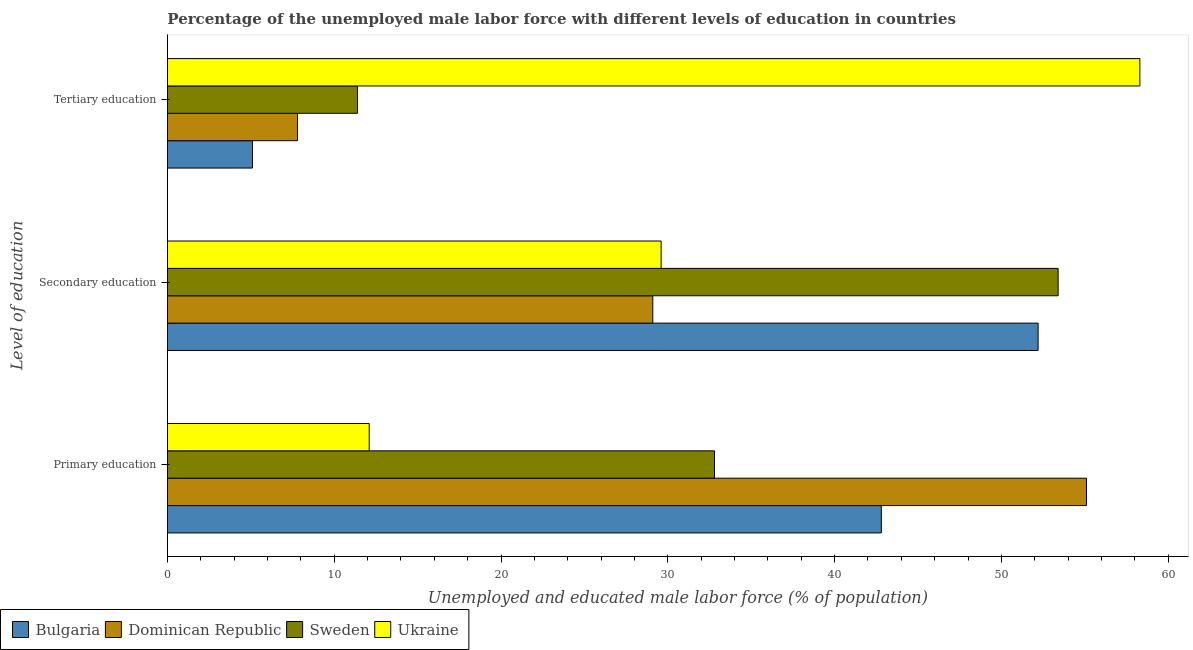How many different coloured bars are there?
Keep it short and to the point. 4. How many groups of bars are there?
Offer a very short reply. 3. Are the number of bars per tick equal to the number of legend labels?
Give a very brief answer. Yes. Are the number of bars on each tick of the Y-axis equal?
Your answer should be very brief. Yes. How many bars are there on the 2nd tick from the bottom?
Offer a very short reply. 4. What is the label of the 1st group of bars from the top?
Your response must be concise. Tertiary education. What is the percentage of male labor force who received tertiary education in Bulgaria?
Offer a terse response. 5.1. Across all countries, what is the maximum percentage of male labor force who received tertiary education?
Your response must be concise. 58.3. Across all countries, what is the minimum percentage of male labor force who received tertiary education?
Your answer should be compact. 5.1. In which country was the percentage of male labor force who received tertiary education maximum?
Give a very brief answer. Ukraine. What is the total percentage of male labor force who received tertiary education in the graph?
Your response must be concise. 82.6. What is the difference between the percentage of male labor force who received primary education in Bulgaria and that in Dominican Republic?
Give a very brief answer. -12.3. What is the difference between the percentage of male labor force who received primary education in Bulgaria and the percentage of male labor force who received secondary education in Dominican Republic?
Provide a short and direct response. 13.7. What is the average percentage of male labor force who received secondary education per country?
Your answer should be compact. 41.08. What is the difference between the percentage of male labor force who received primary education and percentage of male labor force who received secondary education in Ukraine?
Ensure brevity in your answer.  -17.5. In how many countries, is the percentage of male labor force who received primary education greater than 12 %?
Give a very brief answer. 4. What is the ratio of the percentage of male labor force who received primary education in Ukraine to that in Sweden?
Your response must be concise. 0.37. What is the difference between the highest and the second highest percentage of male labor force who received secondary education?
Offer a very short reply. 1.2. What is the difference between the highest and the lowest percentage of male labor force who received primary education?
Make the answer very short. 43. In how many countries, is the percentage of male labor force who received tertiary education greater than the average percentage of male labor force who received tertiary education taken over all countries?
Offer a very short reply. 1. What does the 4th bar from the top in Primary education represents?
Provide a short and direct response. Bulgaria. What does the 4th bar from the bottom in Secondary education represents?
Provide a succinct answer. Ukraine. What is the difference between two consecutive major ticks on the X-axis?
Offer a very short reply. 10. Does the graph contain any zero values?
Your answer should be compact. No. Where does the legend appear in the graph?
Your response must be concise. Bottom left. What is the title of the graph?
Ensure brevity in your answer.  Percentage of the unemployed male labor force with different levels of education in countries. Does "Uzbekistan" appear as one of the legend labels in the graph?
Your answer should be very brief. No. What is the label or title of the X-axis?
Your answer should be very brief. Unemployed and educated male labor force (% of population). What is the label or title of the Y-axis?
Your answer should be very brief. Level of education. What is the Unemployed and educated male labor force (% of population) of Bulgaria in Primary education?
Make the answer very short. 42.8. What is the Unemployed and educated male labor force (% of population) of Dominican Republic in Primary education?
Provide a succinct answer. 55.1. What is the Unemployed and educated male labor force (% of population) of Sweden in Primary education?
Ensure brevity in your answer.  32.8. What is the Unemployed and educated male labor force (% of population) of Ukraine in Primary education?
Your answer should be compact. 12.1. What is the Unemployed and educated male labor force (% of population) of Bulgaria in Secondary education?
Offer a very short reply. 52.2. What is the Unemployed and educated male labor force (% of population) of Dominican Republic in Secondary education?
Offer a very short reply. 29.1. What is the Unemployed and educated male labor force (% of population) of Sweden in Secondary education?
Provide a short and direct response. 53.4. What is the Unemployed and educated male labor force (% of population) of Ukraine in Secondary education?
Your response must be concise. 29.6. What is the Unemployed and educated male labor force (% of population) of Bulgaria in Tertiary education?
Make the answer very short. 5.1. What is the Unemployed and educated male labor force (% of population) in Dominican Republic in Tertiary education?
Ensure brevity in your answer.  7.8. What is the Unemployed and educated male labor force (% of population) in Sweden in Tertiary education?
Your answer should be compact. 11.4. What is the Unemployed and educated male labor force (% of population) in Ukraine in Tertiary education?
Provide a succinct answer. 58.3. Across all Level of education, what is the maximum Unemployed and educated male labor force (% of population) in Bulgaria?
Provide a succinct answer. 52.2. Across all Level of education, what is the maximum Unemployed and educated male labor force (% of population) of Dominican Republic?
Provide a succinct answer. 55.1. Across all Level of education, what is the maximum Unemployed and educated male labor force (% of population) of Sweden?
Give a very brief answer. 53.4. Across all Level of education, what is the maximum Unemployed and educated male labor force (% of population) in Ukraine?
Make the answer very short. 58.3. Across all Level of education, what is the minimum Unemployed and educated male labor force (% of population) in Bulgaria?
Offer a terse response. 5.1. Across all Level of education, what is the minimum Unemployed and educated male labor force (% of population) of Dominican Republic?
Provide a succinct answer. 7.8. Across all Level of education, what is the minimum Unemployed and educated male labor force (% of population) of Sweden?
Offer a very short reply. 11.4. Across all Level of education, what is the minimum Unemployed and educated male labor force (% of population) of Ukraine?
Offer a terse response. 12.1. What is the total Unemployed and educated male labor force (% of population) in Bulgaria in the graph?
Make the answer very short. 100.1. What is the total Unemployed and educated male labor force (% of population) of Dominican Republic in the graph?
Keep it short and to the point. 92. What is the total Unemployed and educated male labor force (% of population) in Sweden in the graph?
Make the answer very short. 97.6. What is the difference between the Unemployed and educated male labor force (% of population) of Bulgaria in Primary education and that in Secondary education?
Offer a terse response. -9.4. What is the difference between the Unemployed and educated male labor force (% of population) of Sweden in Primary education and that in Secondary education?
Your answer should be compact. -20.6. What is the difference between the Unemployed and educated male labor force (% of population) in Ukraine in Primary education and that in Secondary education?
Your response must be concise. -17.5. What is the difference between the Unemployed and educated male labor force (% of population) in Bulgaria in Primary education and that in Tertiary education?
Offer a terse response. 37.7. What is the difference between the Unemployed and educated male labor force (% of population) of Dominican Republic in Primary education and that in Tertiary education?
Offer a very short reply. 47.3. What is the difference between the Unemployed and educated male labor force (% of population) in Sweden in Primary education and that in Tertiary education?
Ensure brevity in your answer.  21.4. What is the difference between the Unemployed and educated male labor force (% of population) in Ukraine in Primary education and that in Tertiary education?
Your answer should be very brief. -46.2. What is the difference between the Unemployed and educated male labor force (% of population) in Bulgaria in Secondary education and that in Tertiary education?
Provide a succinct answer. 47.1. What is the difference between the Unemployed and educated male labor force (% of population) of Dominican Republic in Secondary education and that in Tertiary education?
Provide a short and direct response. 21.3. What is the difference between the Unemployed and educated male labor force (% of population) in Ukraine in Secondary education and that in Tertiary education?
Your answer should be very brief. -28.7. What is the difference between the Unemployed and educated male labor force (% of population) in Dominican Republic in Primary education and the Unemployed and educated male labor force (% of population) in Sweden in Secondary education?
Your response must be concise. 1.7. What is the difference between the Unemployed and educated male labor force (% of population) of Dominican Republic in Primary education and the Unemployed and educated male labor force (% of population) of Ukraine in Secondary education?
Offer a very short reply. 25.5. What is the difference between the Unemployed and educated male labor force (% of population) in Bulgaria in Primary education and the Unemployed and educated male labor force (% of population) in Dominican Republic in Tertiary education?
Offer a very short reply. 35. What is the difference between the Unemployed and educated male labor force (% of population) in Bulgaria in Primary education and the Unemployed and educated male labor force (% of population) in Sweden in Tertiary education?
Offer a terse response. 31.4. What is the difference between the Unemployed and educated male labor force (% of population) of Bulgaria in Primary education and the Unemployed and educated male labor force (% of population) of Ukraine in Tertiary education?
Keep it short and to the point. -15.5. What is the difference between the Unemployed and educated male labor force (% of population) of Dominican Republic in Primary education and the Unemployed and educated male labor force (% of population) of Sweden in Tertiary education?
Offer a very short reply. 43.7. What is the difference between the Unemployed and educated male labor force (% of population) in Dominican Republic in Primary education and the Unemployed and educated male labor force (% of population) in Ukraine in Tertiary education?
Your answer should be very brief. -3.2. What is the difference between the Unemployed and educated male labor force (% of population) of Sweden in Primary education and the Unemployed and educated male labor force (% of population) of Ukraine in Tertiary education?
Your answer should be very brief. -25.5. What is the difference between the Unemployed and educated male labor force (% of population) of Bulgaria in Secondary education and the Unemployed and educated male labor force (% of population) of Dominican Republic in Tertiary education?
Provide a short and direct response. 44.4. What is the difference between the Unemployed and educated male labor force (% of population) in Bulgaria in Secondary education and the Unemployed and educated male labor force (% of population) in Sweden in Tertiary education?
Your answer should be very brief. 40.8. What is the difference between the Unemployed and educated male labor force (% of population) in Dominican Republic in Secondary education and the Unemployed and educated male labor force (% of population) in Ukraine in Tertiary education?
Provide a succinct answer. -29.2. What is the average Unemployed and educated male labor force (% of population) in Bulgaria per Level of education?
Make the answer very short. 33.37. What is the average Unemployed and educated male labor force (% of population) in Dominican Republic per Level of education?
Provide a succinct answer. 30.67. What is the average Unemployed and educated male labor force (% of population) in Sweden per Level of education?
Provide a short and direct response. 32.53. What is the average Unemployed and educated male labor force (% of population) in Ukraine per Level of education?
Provide a succinct answer. 33.33. What is the difference between the Unemployed and educated male labor force (% of population) of Bulgaria and Unemployed and educated male labor force (% of population) of Ukraine in Primary education?
Your response must be concise. 30.7. What is the difference between the Unemployed and educated male labor force (% of population) of Dominican Republic and Unemployed and educated male labor force (% of population) of Sweden in Primary education?
Offer a terse response. 22.3. What is the difference between the Unemployed and educated male labor force (% of population) in Dominican Republic and Unemployed and educated male labor force (% of population) in Ukraine in Primary education?
Your answer should be compact. 43. What is the difference between the Unemployed and educated male labor force (% of population) in Sweden and Unemployed and educated male labor force (% of population) in Ukraine in Primary education?
Make the answer very short. 20.7. What is the difference between the Unemployed and educated male labor force (% of population) of Bulgaria and Unemployed and educated male labor force (% of population) of Dominican Republic in Secondary education?
Keep it short and to the point. 23.1. What is the difference between the Unemployed and educated male labor force (% of population) of Bulgaria and Unemployed and educated male labor force (% of population) of Ukraine in Secondary education?
Ensure brevity in your answer.  22.6. What is the difference between the Unemployed and educated male labor force (% of population) of Dominican Republic and Unemployed and educated male labor force (% of population) of Sweden in Secondary education?
Offer a very short reply. -24.3. What is the difference between the Unemployed and educated male labor force (% of population) in Sweden and Unemployed and educated male labor force (% of population) in Ukraine in Secondary education?
Make the answer very short. 23.8. What is the difference between the Unemployed and educated male labor force (% of population) of Bulgaria and Unemployed and educated male labor force (% of population) of Dominican Republic in Tertiary education?
Ensure brevity in your answer.  -2.7. What is the difference between the Unemployed and educated male labor force (% of population) of Bulgaria and Unemployed and educated male labor force (% of population) of Sweden in Tertiary education?
Ensure brevity in your answer.  -6.3. What is the difference between the Unemployed and educated male labor force (% of population) in Bulgaria and Unemployed and educated male labor force (% of population) in Ukraine in Tertiary education?
Keep it short and to the point. -53.2. What is the difference between the Unemployed and educated male labor force (% of population) in Dominican Republic and Unemployed and educated male labor force (% of population) in Ukraine in Tertiary education?
Offer a terse response. -50.5. What is the difference between the Unemployed and educated male labor force (% of population) in Sweden and Unemployed and educated male labor force (% of population) in Ukraine in Tertiary education?
Offer a terse response. -46.9. What is the ratio of the Unemployed and educated male labor force (% of population) of Bulgaria in Primary education to that in Secondary education?
Provide a short and direct response. 0.82. What is the ratio of the Unemployed and educated male labor force (% of population) of Dominican Republic in Primary education to that in Secondary education?
Give a very brief answer. 1.89. What is the ratio of the Unemployed and educated male labor force (% of population) of Sweden in Primary education to that in Secondary education?
Offer a very short reply. 0.61. What is the ratio of the Unemployed and educated male labor force (% of population) of Ukraine in Primary education to that in Secondary education?
Your answer should be compact. 0.41. What is the ratio of the Unemployed and educated male labor force (% of population) in Bulgaria in Primary education to that in Tertiary education?
Your answer should be compact. 8.39. What is the ratio of the Unemployed and educated male labor force (% of population) of Dominican Republic in Primary education to that in Tertiary education?
Make the answer very short. 7.06. What is the ratio of the Unemployed and educated male labor force (% of population) of Sweden in Primary education to that in Tertiary education?
Provide a short and direct response. 2.88. What is the ratio of the Unemployed and educated male labor force (% of population) of Ukraine in Primary education to that in Tertiary education?
Offer a terse response. 0.21. What is the ratio of the Unemployed and educated male labor force (% of population) of Bulgaria in Secondary education to that in Tertiary education?
Keep it short and to the point. 10.24. What is the ratio of the Unemployed and educated male labor force (% of population) in Dominican Republic in Secondary education to that in Tertiary education?
Offer a terse response. 3.73. What is the ratio of the Unemployed and educated male labor force (% of population) in Sweden in Secondary education to that in Tertiary education?
Ensure brevity in your answer.  4.68. What is the ratio of the Unemployed and educated male labor force (% of population) in Ukraine in Secondary education to that in Tertiary education?
Provide a succinct answer. 0.51. What is the difference between the highest and the second highest Unemployed and educated male labor force (% of population) in Bulgaria?
Your answer should be very brief. 9.4. What is the difference between the highest and the second highest Unemployed and educated male labor force (% of population) in Dominican Republic?
Your answer should be very brief. 26. What is the difference between the highest and the second highest Unemployed and educated male labor force (% of population) in Sweden?
Your answer should be compact. 20.6. What is the difference between the highest and the second highest Unemployed and educated male labor force (% of population) in Ukraine?
Provide a short and direct response. 28.7. What is the difference between the highest and the lowest Unemployed and educated male labor force (% of population) of Bulgaria?
Keep it short and to the point. 47.1. What is the difference between the highest and the lowest Unemployed and educated male labor force (% of population) of Dominican Republic?
Offer a terse response. 47.3. What is the difference between the highest and the lowest Unemployed and educated male labor force (% of population) of Sweden?
Your answer should be compact. 42. What is the difference between the highest and the lowest Unemployed and educated male labor force (% of population) of Ukraine?
Provide a short and direct response. 46.2. 